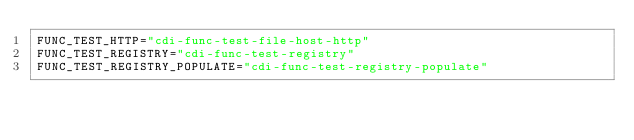<code> <loc_0><loc_0><loc_500><loc_500><_Bash_>FUNC_TEST_HTTP="cdi-func-test-file-host-http"
FUNC_TEST_REGISTRY="cdi-func-test-registry"
FUNC_TEST_REGISTRY_POPULATE="cdi-func-test-registry-populate"</code> 